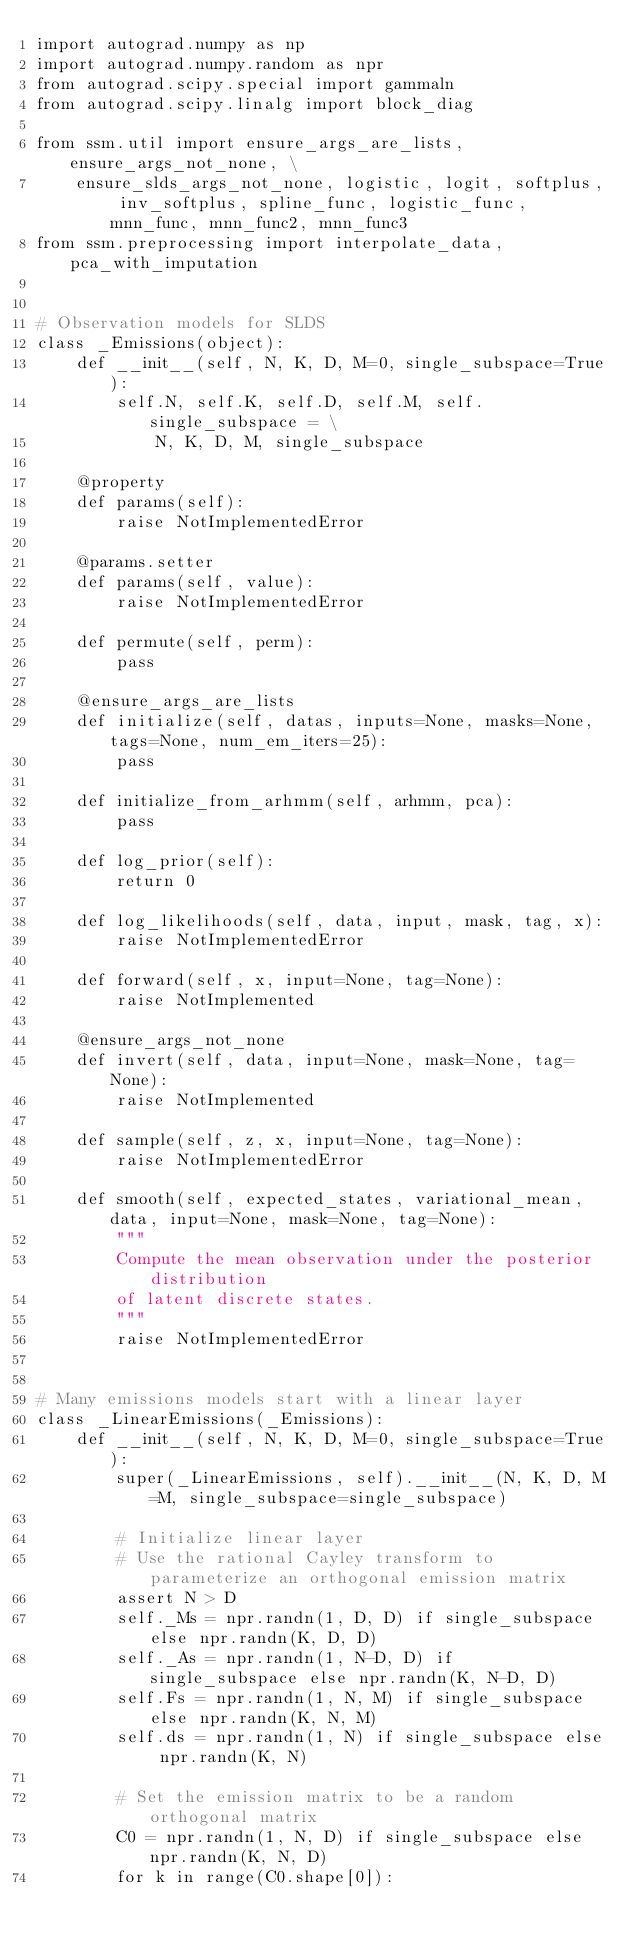<code> <loc_0><loc_0><loc_500><loc_500><_Python_>import autograd.numpy as np
import autograd.numpy.random as npr
from autograd.scipy.special import gammaln
from autograd.scipy.linalg import block_diag

from ssm.util import ensure_args_are_lists, ensure_args_not_none, \
    ensure_slds_args_not_none, logistic, logit, softplus, inv_softplus, spline_func, logistic_func, mnn_func, mnn_func2, mnn_func3
from ssm.preprocessing import interpolate_data, pca_with_imputation


# Observation models for SLDS
class _Emissions(object):
    def __init__(self, N, K, D, M=0, single_subspace=True):
        self.N, self.K, self.D, self.M, self.single_subspace = \
            N, K, D, M, single_subspace

    @property
    def params(self):
        raise NotImplementedError

    @params.setter
    def params(self, value):
        raise NotImplementedError

    def permute(self, perm):
        pass

    @ensure_args_are_lists
    def initialize(self, datas, inputs=None, masks=None, tags=None, num_em_iters=25):
        pass

    def initialize_from_arhmm(self, arhmm, pca):
        pass

    def log_prior(self):
        return 0

    def log_likelihoods(self, data, input, mask, tag, x):
        raise NotImplementedError

    def forward(self, x, input=None, tag=None):
        raise NotImplemented

    @ensure_args_not_none
    def invert(self, data, input=None, mask=None, tag=None):
        raise NotImplemented

    def sample(self, z, x, input=None, tag=None):
        raise NotImplementedError

    def smooth(self, expected_states, variational_mean, data, input=None, mask=None, tag=None):
        """
        Compute the mean observation under the posterior distribution
        of latent discrete states.
        """
        raise NotImplementedError


# Many emissions models start with a linear layer
class _LinearEmissions(_Emissions):
    def __init__(self, N, K, D, M=0, single_subspace=True):
        super(_LinearEmissions, self).__init__(N, K, D, M=M, single_subspace=single_subspace)

        # Initialize linear layer
        # Use the rational Cayley transform to parameterize an orthogonal emission matrix
        assert N > D
        self._Ms = npr.randn(1, D, D) if single_subspace else npr.randn(K, D, D)
        self._As = npr.randn(1, N-D, D) if single_subspace else npr.randn(K, N-D, D)
        self.Fs = npr.randn(1, N, M) if single_subspace else npr.randn(K, N, M)
        self.ds = npr.randn(1, N) if single_subspace else npr.randn(K, N)

        # Set the emission matrix to be a random orthogonal matrix
        C0 = npr.randn(1, N, D) if single_subspace else npr.randn(K, N, D)
        for k in range(C0.shape[0]):</code> 